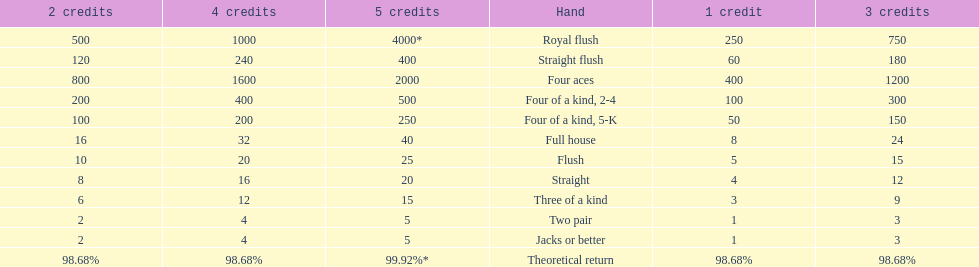Which hand is the top hand in the card game super aces? Royal flush. 